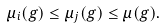Convert formula to latex. <formula><loc_0><loc_0><loc_500><loc_500>\mu _ { i } ( g ) \leq \mu _ { j } ( g ) \leq \mu ( g ) .</formula> 